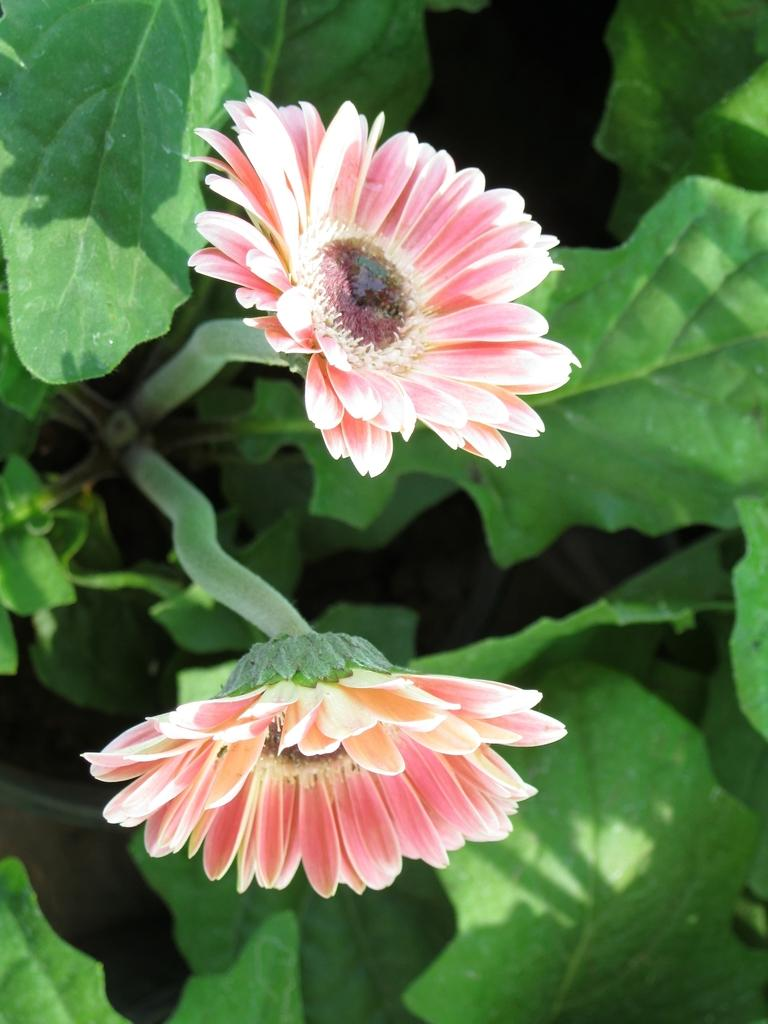How many daisy flowers are in the image? There are two daisy flowers in the image. What is the main feature of the daisy flowers? The daisy flowers have plants in the image. What type of bag can be seen in the design of the daisy flowers? There is no bag present in the image, as it features two daisy flowers with plants. 